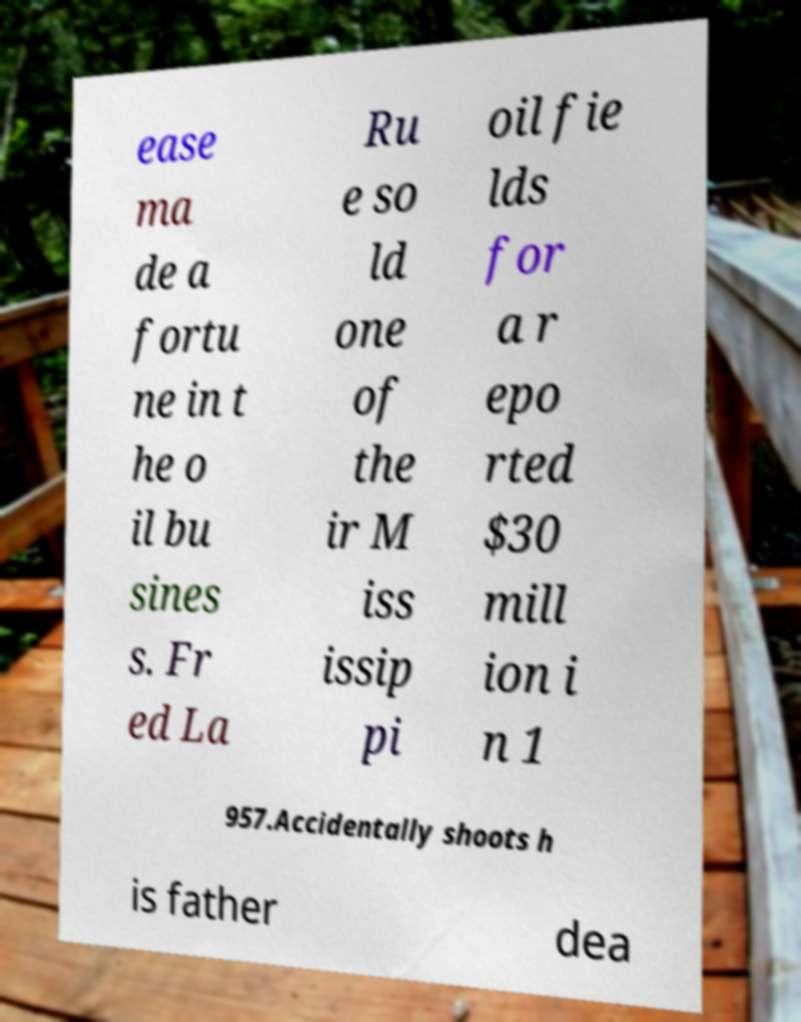Can you read and provide the text displayed in the image?This photo seems to have some interesting text. Can you extract and type it out for me? ease ma de a fortu ne in t he o il bu sines s. Fr ed La Ru e so ld one of the ir M iss issip pi oil fie lds for a r epo rted $30 mill ion i n 1 957.Accidentally shoots h is father dea 